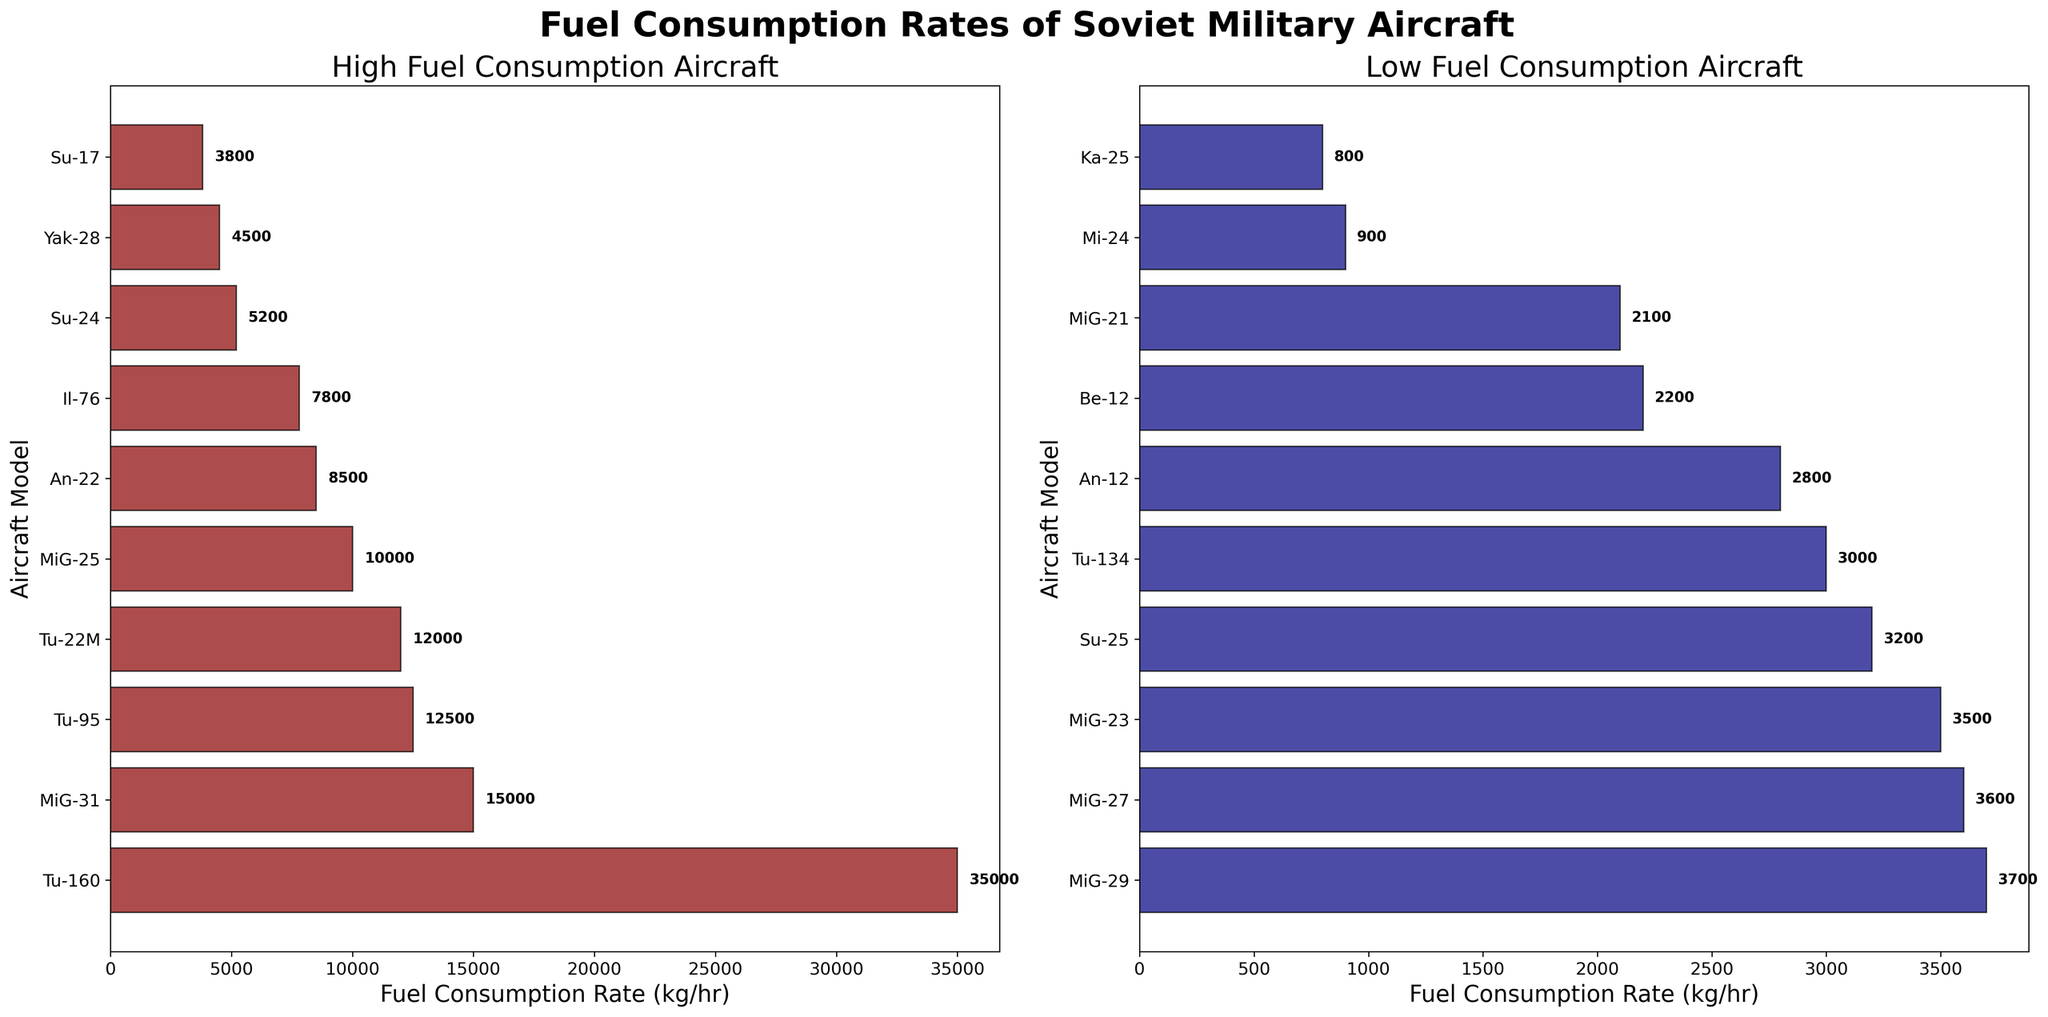Which aircraft has the highest fuel consumption rate? Tu-160 has the highest fuel consumption rate, shown as the longest bar in the high fuel consumption aircraft subplot with a value of 35,000 kg/hr.
Answer: Tu-160 How many aircraft models have a fuel consumption rate greater than 10,000 kg/hr? From the high consumption subplot, the aircraft models with a fuel consumption rate greater than 10,000 kg/hr are Tu-22M (12,000 kg/hr), Tu-95 (12,500 kg/hr), MiG-31 (15,000 kg/hr), and Tu-160 (35,000 kg/hr), totaling 4 models.
Answer: 4 What is the total fuel consumption rate of the lowest five consuming aircraft? The lowest five consuming aircraft (from the low consumption subplot) are Mi-24 (900 kg/hr), Ka-25 (800 kg/hr), Be-12 (2,200 kg/hr), MiG-21 (2,100 kg/hr), and An-12 (2,800 kg/hr). The total is 900 + 800 + 2,200 + 2,100 + 2,800 = 8,800 kg/hr.
Answer: 8,800 kg/hr Which aircraft model consumes more fuel, the Su-25 or the MiG-27, and by how much? In the high fuel consumption subplot, MiG-27 consumes 3,600 kg/hr, and in the low consumption subplot, Su-25 consumes 3,200 kg/hr. The difference is 3,600 - 3,200 = 400 kg/hr.
Answer: MiG-27, by 400 kg/hr What is the average fuel consumption rate of the low fuel consumption aircraft? The low consumption subplot lists ten aircraft: Be-12 (2,200), MiG-21 (2,100), An-12 (2,800), Tu-134 (3,000), Su-25 (3,200), Ka-25 (800), Mi-24 (900). Summing these values: 2,200 + 2,100 + 2,800 + 3,000 + 3,200 + 2,800 + 800 + 900 = 17,800 kg/hr. Dividing by 10 gives 17,800 / 10 = 1,780 kg/hr.
Answer: 1,780 kg/hr 